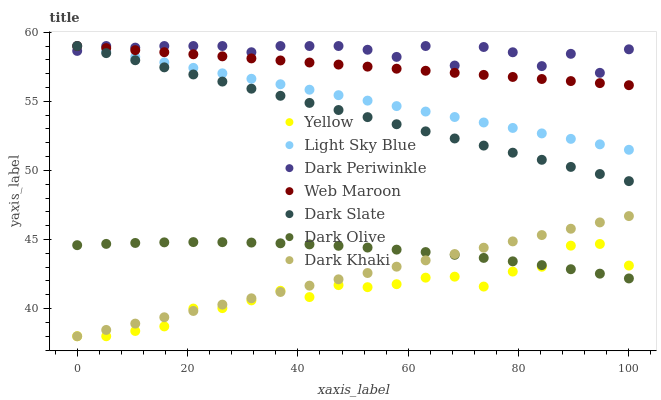Does Yellow have the minimum area under the curve?
Answer yes or no. Yes. Does Dark Periwinkle have the maximum area under the curve?
Answer yes or no. Yes. Does Web Maroon have the minimum area under the curve?
Answer yes or no. No. Does Web Maroon have the maximum area under the curve?
Answer yes or no. No. Is Web Maroon the smoothest?
Answer yes or no. Yes. Is Dark Periwinkle the roughest?
Answer yes or no. Yes. Is Yellow the smoothest?
Answer yes or no. No. Is Yellow the roughest?
Answer yes or no. No. Does Yellow have the lowest value?
Answer yes or no. Yes. Does Web Maroon have the lowest value?
Answer yes or no. No. Does Dark Periwinkle have the highest value?
Answer yes or no. Yes. Does Yellow have the highest value?
Answer yes or no. No. Is Dark Olive less than Dark Slate?
Answer yes or no. Yes. Is Web Maroon greater than Yellow?
Answer yes or no. Yes. Does Dark Periwinkle intersect Web Maroon?
Answer yes or no. Yes. Is Dark Periwinkle less than Web Maroon?
Answer yes or no. No. Is Dark Periwinkle greater than Web Maroon?
Answer yes or no. No. Does Dark Olive intersect Dark Slate?
Answer yes or no. No. 